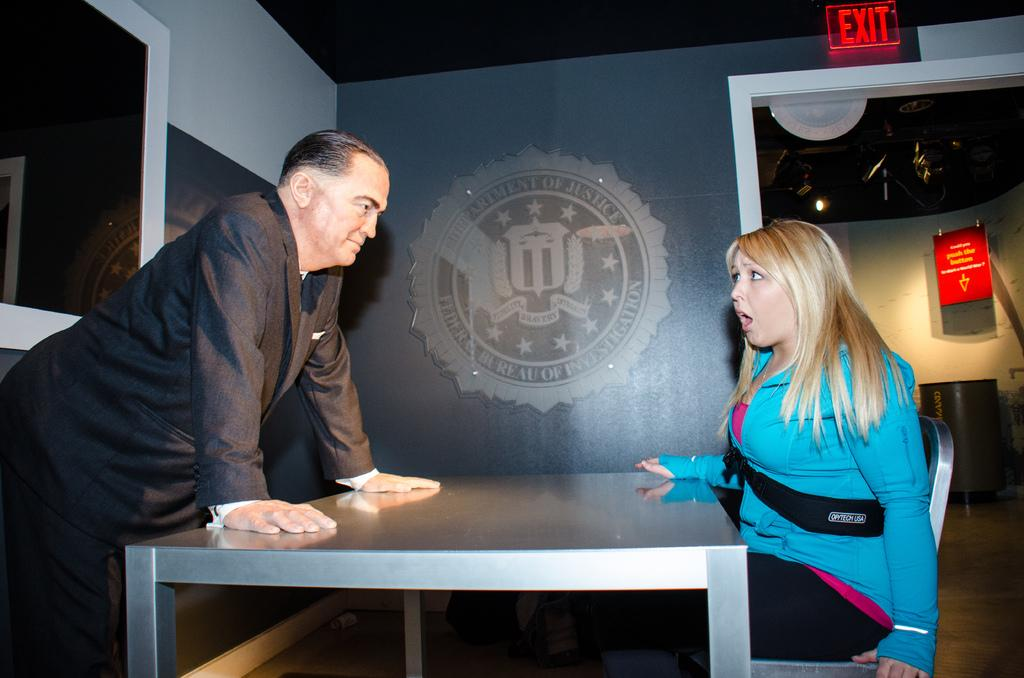How many people are in the image? There are two people in the image. Can you describe one of the people? One of the people is a woman. What is the woman doing in the image? The woman is sitting on a chair. What is in front of the people in the image? There is a table in front of the people. What can be seen in the background of the image? There is a wall and an exit sign board in the background of the image. What type of rabbit can be seen hopping on the table in the image? There is no rabbit present in the image; it only features two people, a table, and a wall with an exit sign board in the background. How many men are in the image? The image only features one woman and one other person, but their gender is not specified, so we cannot definitively say if there is a man in the image. 